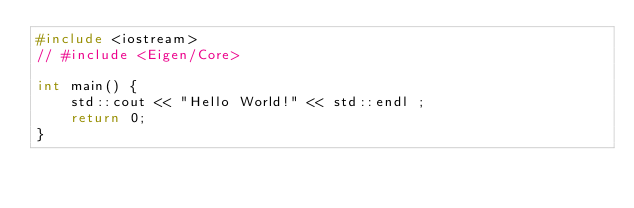Convert code to text. <code><loc_0><loc_0><loc_500><loc_500><_C++_>#include <iostream>
// #include <Eigen/Core>

int main() {
    std::cout << "Hello World!" << std::endl ;
    return 0;
}</code> 